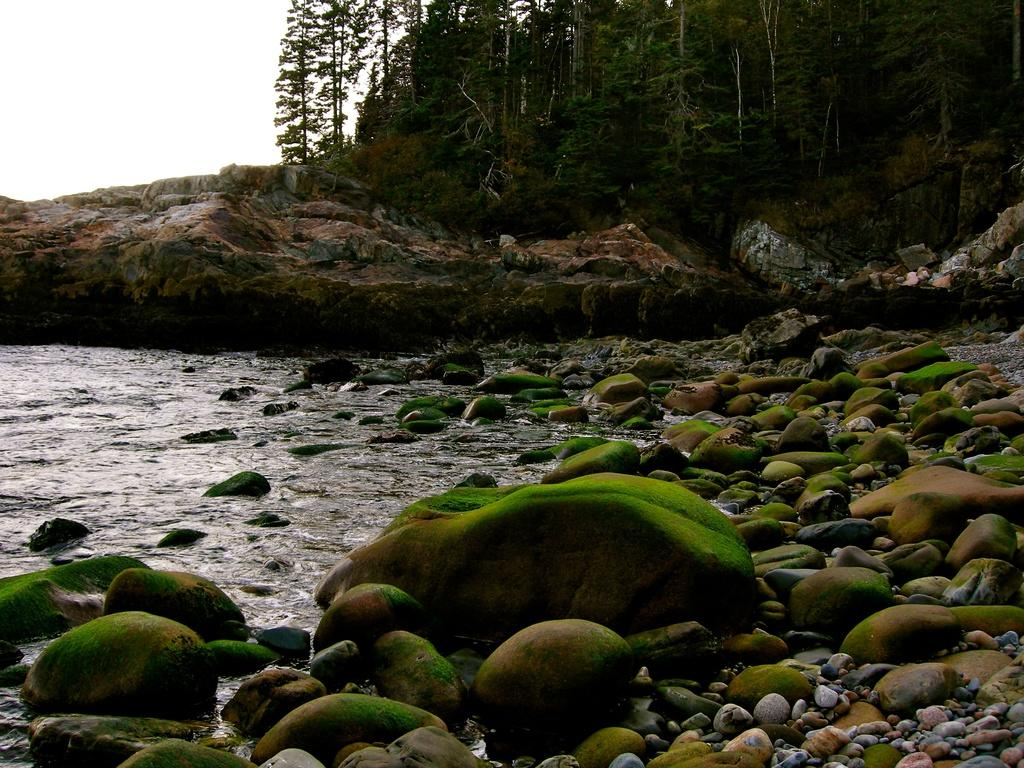What type of natural elements can be seen in the image? There are stones, water, mountains, and trees visible in the image. What is the condition of the sky in the image? The sky is visible in the image, and it is likely taken during the day. Can you describe the landscape in the image? The image may have been taken near the ocean, and there are mountains and trees present. What type of rabbit can be seen wearing a skirt in the image? There is no rabbit or skirt present in the image. What level of experience does the beginner have in the image? There is no indication of any person or activity related to a beginner in the image. 